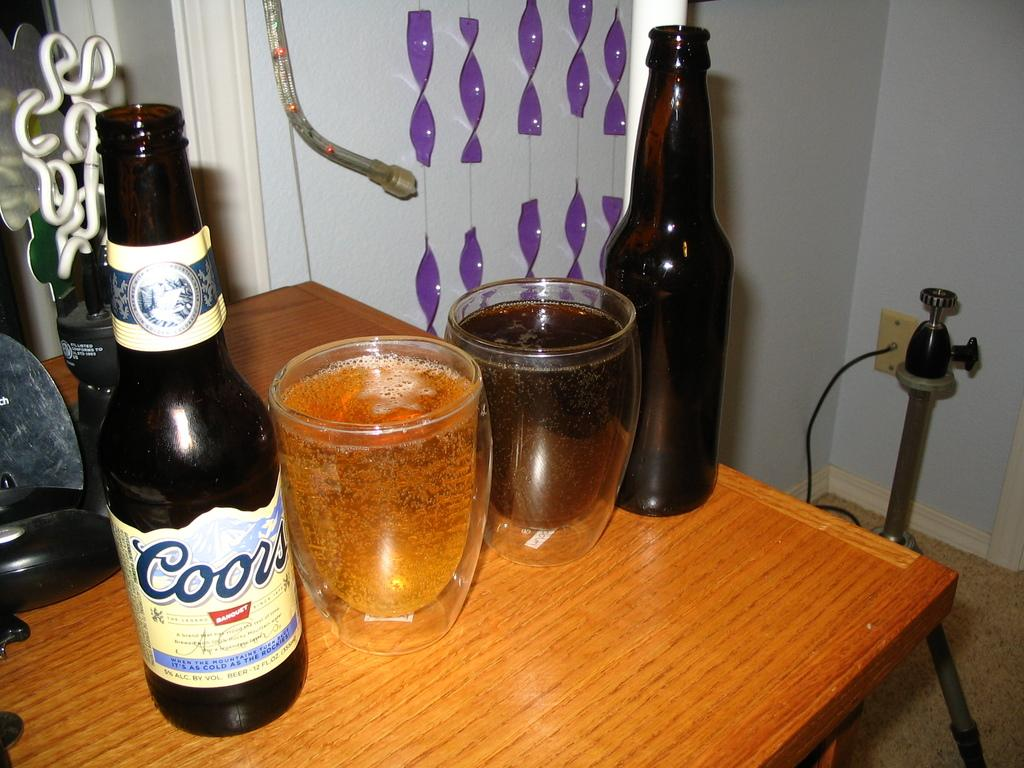Provide a one-sentence caption for the provided image. A bottle of Coors beer and another bottle is sitting on a table with two glasses of beer between them. 